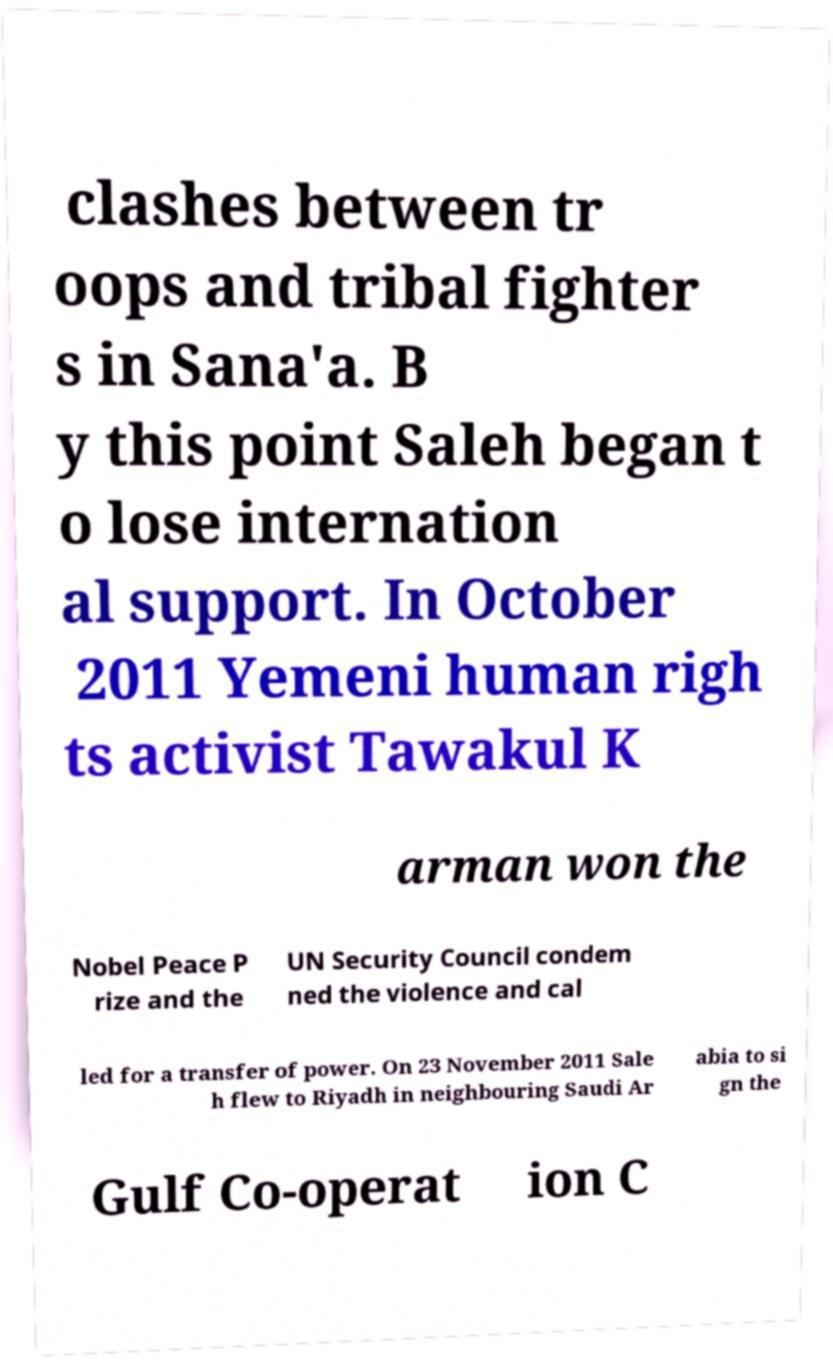Can you read and provide the text displayed in the image?This photo seems to have some interesting text. Can you extract and type it out for me? clashes between tr oops and tribal fighter s in Sana'a. B y this point Saleh began t o lose internation al support. In October 2011 Yemeni human righ ts activist Tawakul K arman won the Nobel Peace P rize and the UN Security Council condem ned the violence and cal led for a transfer of power. On 23 November 2011 Sale h flew to Riyadh in neighbouring Saudi Ar abia to si gn the Gulf Co-operat ion C 